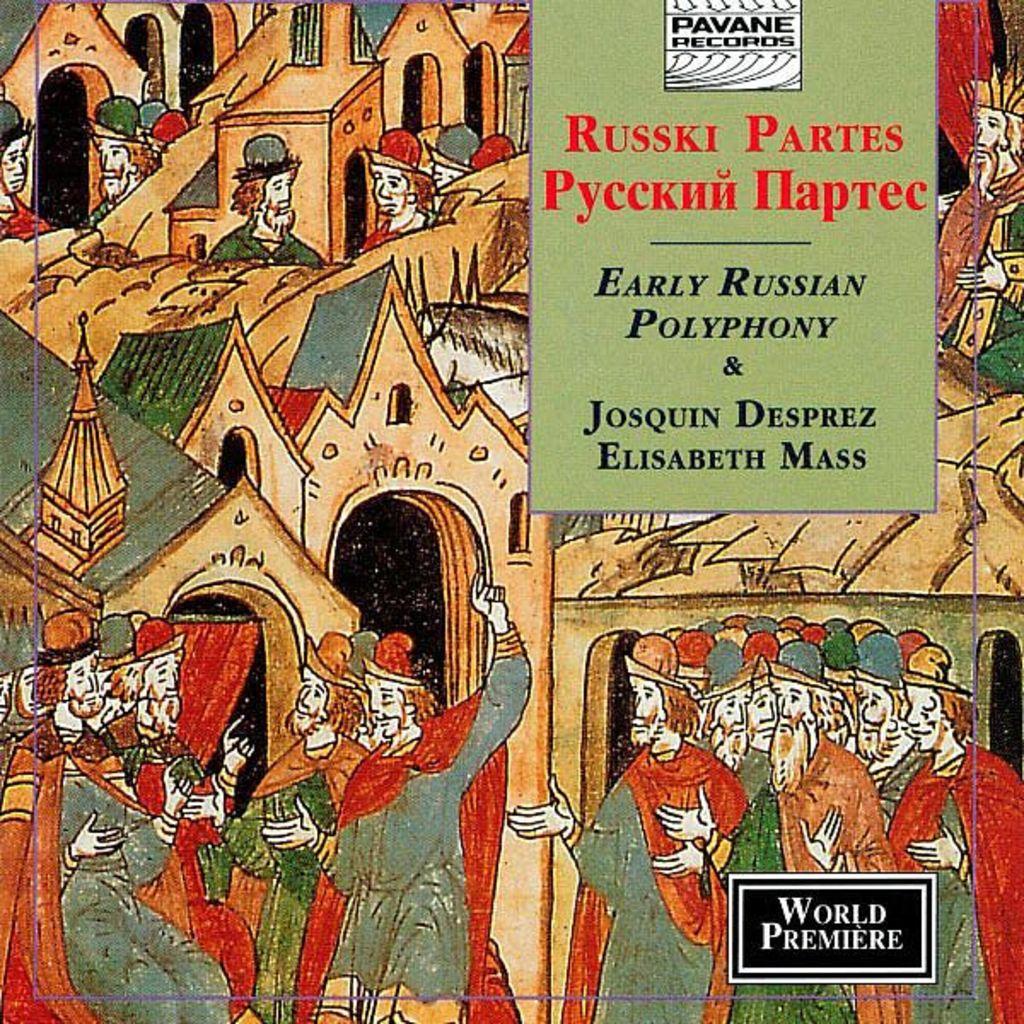What does it say in the bottom right corner?
Give a very brief answer. World premiere. What is the name of the record company?
Offer a very short reply. Pavane records. 